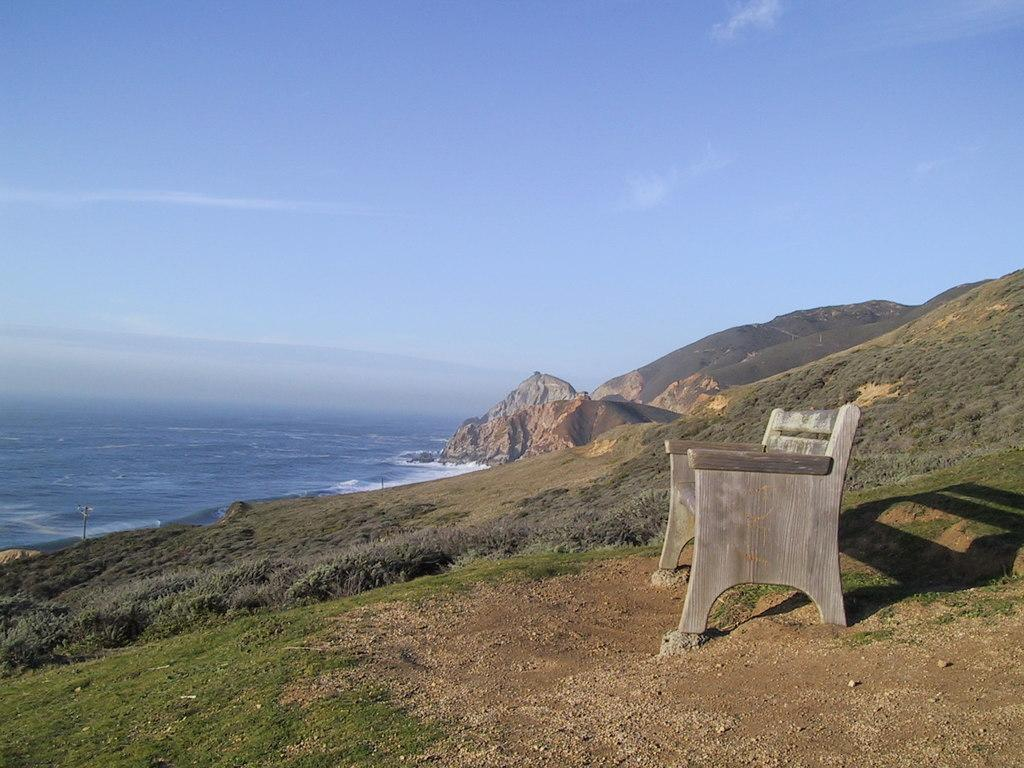What type of seating is present in the image? There is a bench in the image. What type of landscape can be seen in the image? There are hills and grass visible in the image. What natural feature is visible in the distance? The sea is visible in the image. What else can be seen in the sky besides the hills and grass? The sky is visible in the image. What type of twig is being used to support the bench in the image? There is no twig present in the image, and the bench is not supported by any visible twig. How many legs does the bench have in the image? The image does not show the legs of the bench, so it is impossible to determine the number of legs from the image. 